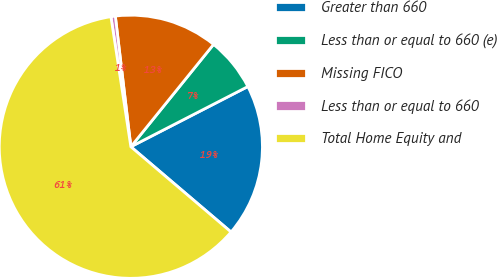Convert chart to OTSL. <chart><loc_0><loc_0><loc_500><loc_500><pie_chart><fcel>Greater than 660<fcel>Less than or equal to 660 (e)<fcel>Missing FICO<fcel>Less than or equal to 660<fcel>Total Home Equity and<nl><fcel>18.78%<fcel>6.62%<fcel>12.7%<fcel>0.54%<fcel>61.35%<nl></chart> 